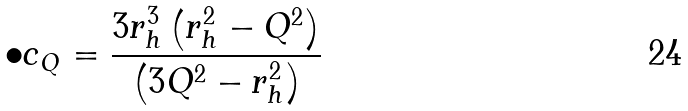<formula> <loc_0><loc_0><loc_500><loc_500>\bullet c _ { Q } = \frac { 3 r _ { h } ^ { 3 } \left ( r _ { h } ^ { 2 } - Q ^ { 2 } \right ) } { \left ( 3 Q ^ { 2 } - r _ { h } ^ { 2 } \right ) }</formula> 